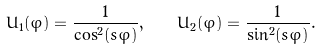Convert formula to latex. <formula><loc_0><loc_0><loc_500><loc_500>U _ { 1 } ( \varphi ) = \frac { 1 } { \cos ^ { 2 } ( s \varphi ) } , \quad U _ { 2 } ( \varphi ) = \frac { 1 } { \sin ^ { 2 } ( s \varphi ) } .</formula> 